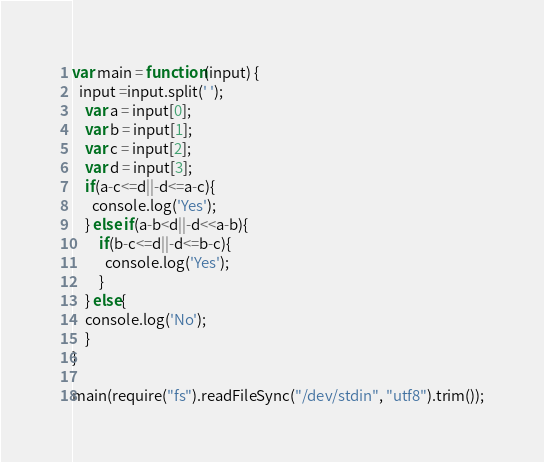<code> <loc_0><loc_0><loc_500><loc_500><_JavaScript_>var main = function(input) {
  input =input.split(' ');
	var a = input[0];
    var b = input[1];
    var c = input[2];
    var d = input[3];
  	if(a-c<=d||-d<=a-c){
      console.log('Yes');
    } else if(a-b<d||-d<<a-b){
      	if(b-c<=d||-d<=b-c){
          console.log('Yes');
        }
    } else{
    console.log('No');
    }
}

main(require("fs").readFileSync("/dev/stdin", "utf8").trim());</code> 